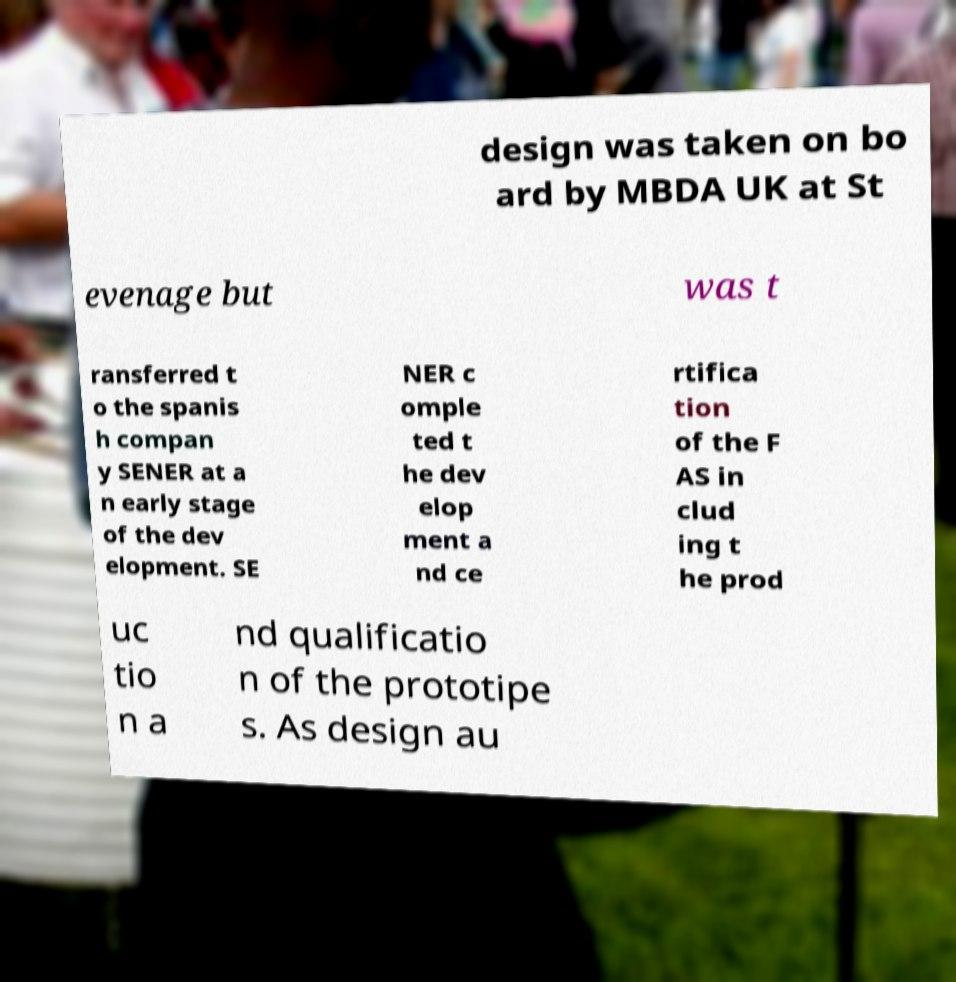Please identify and transcribe the text found in this image. design was taken on bo ard by MBDA UK at St evenage but was t ransferred t o the spanis h compan y SENER at a n early stage of the dev elopment. SE NER c omple ted t he dev elop ment a nd ce rtifica tion of the F AS in clud ing t he prod uc tio n a nd qualificatio n of the prototipe s. As design au 